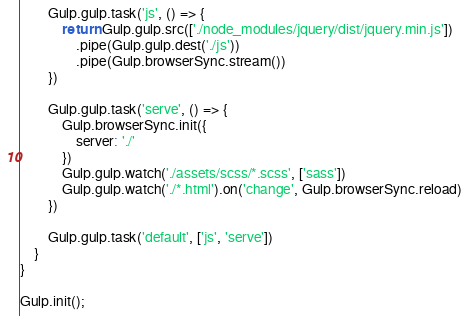Convert code to text. <code><loc_0><loc_0><loc_500><loc_500><_JavaScript_>		Gulp.gulp.task('js', () => {
			return Gulp.gulp.src(['./node_modules/jquery/dist/jquery.min.js'])
				.pipe(Gulp.gulp.dest('./js'))
				.pipe(Gulp.browserSync.stream())
		})

		Gulp.gulp.task('serve', () => {
			Gulp.browserSync.init({
				server: './'
			})
			Gulp.gulp.watch('./assets/scss/*.scss', ['sass'])
			Gulp.gulp.watch('./*.html').on('change', Gulp.browserSync.reload)
		})

		Gulp.gulp.task('default', ['js', 'serve'])
    }
}

Gulp.init();</code> 